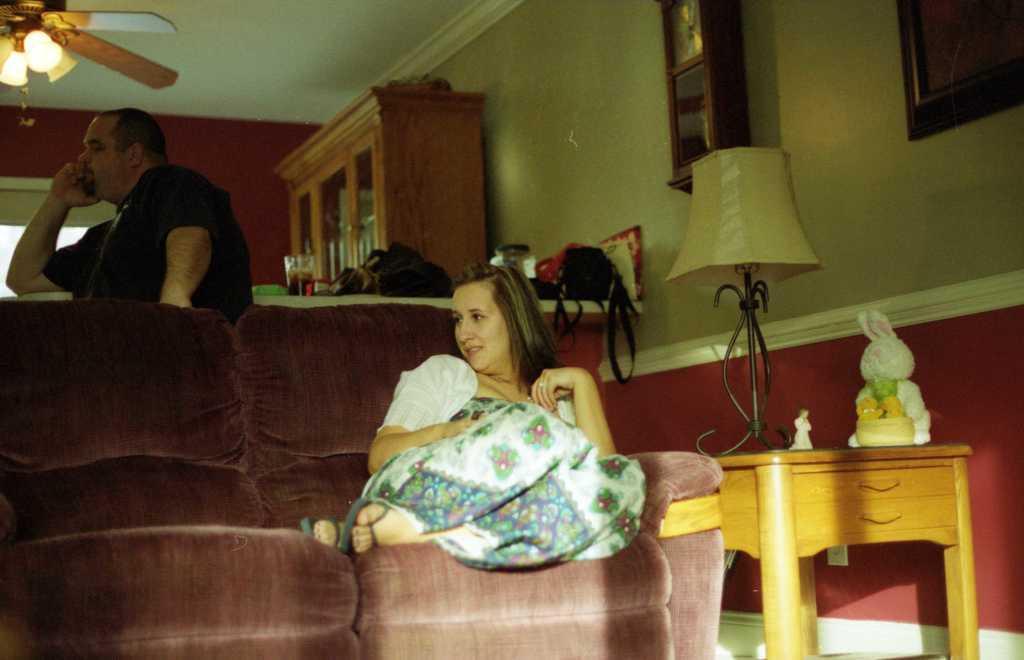Describe this image in one or two sentences. In this image, there is a sofa which is in brown color, on that sofa there's a girl sitting, in the right side there is a table which is in yellow color, on that table there is a white color toy and there is a white color lamp kept on the table, in the background there is a man sitting and there is a brown color box, there is a white color wall and there is a red color wall. 